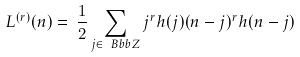<formula> <loc_0><loc_0><loc_500><loc_500>L ^ { ( r ) } ( n ) = \, \frac { 1 } { 2 } \sum _ { j \in \ B b b Z } j ^ { r } h ( j ) ( n - j ) ^ { r } h ( n - j ) \,</formula> 